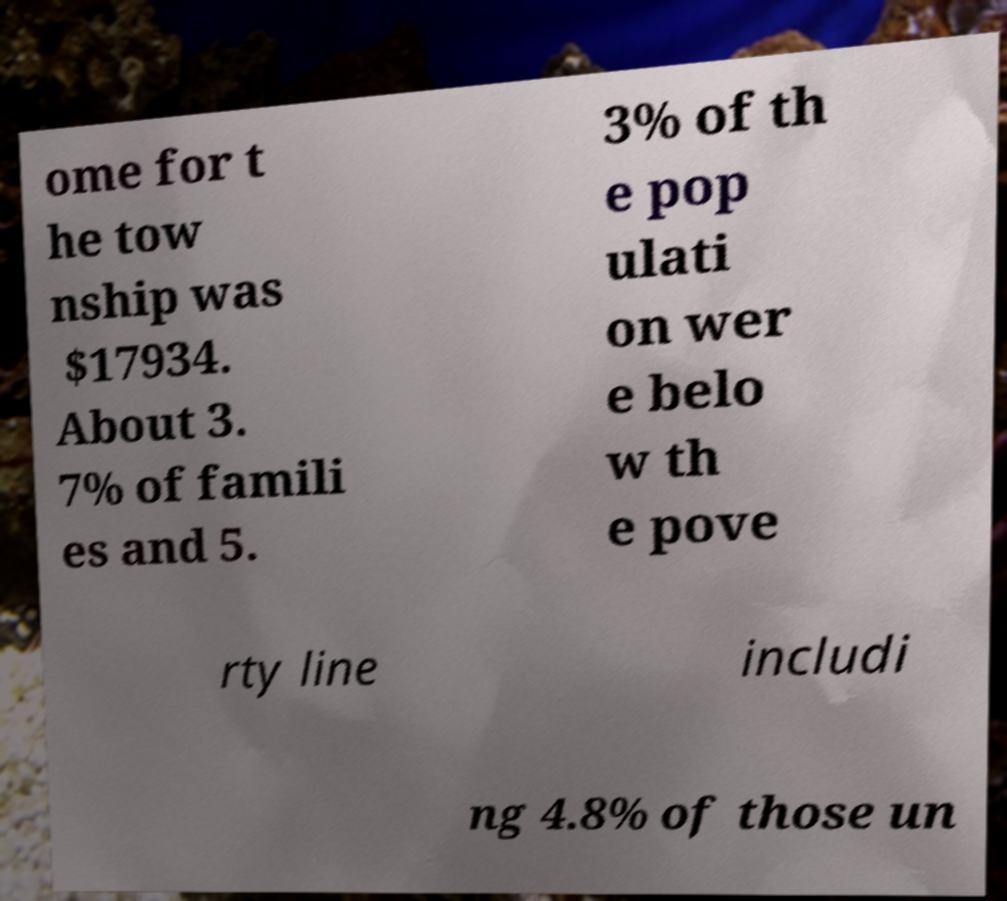Could you assist in decoding the text presented in this image and type it out clearly? ome for t he tow nship was $17934. About 3. 7% of famili es and 5. 3% of th e pop ulati on wer e belo w th e pove rty line includi ng 4.8% of those un 